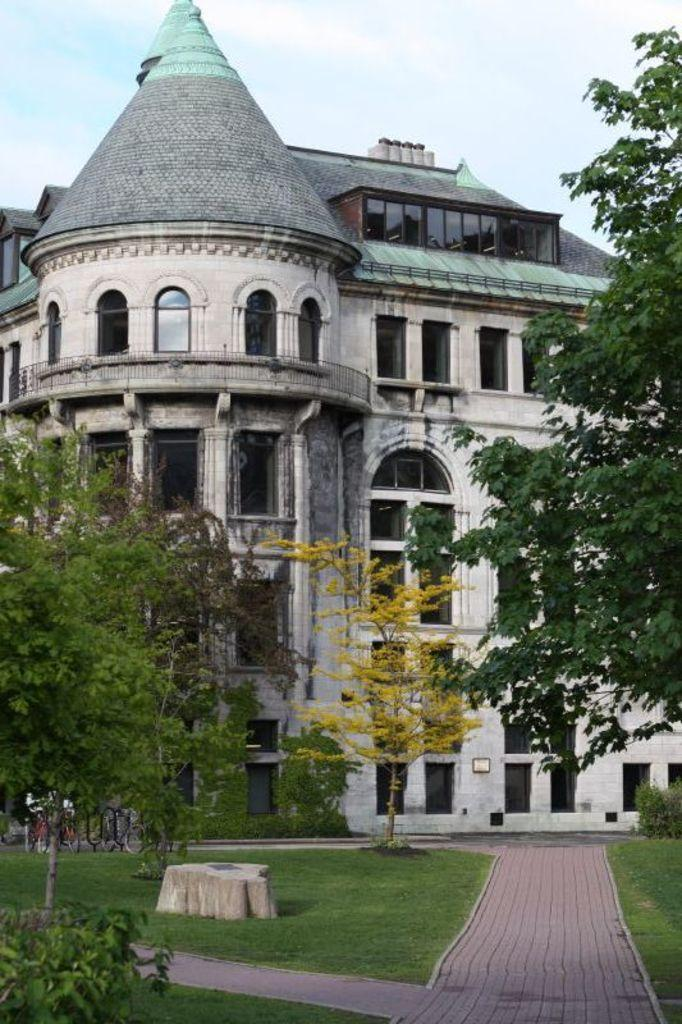What type of surface can be seen in the image? There is a path in the image. What is covering the ground in the image? There is grass on the ground in the image. What type of vegetation is present in the image? There are trees in the image. What type of transportation can be seen in the image? There are bicycles in the image. What type of structure is present in the image? There is a building in the image. What colors are the building in the image? The building is cream, black, and green in color. What is visible in the background of the image? The sky is visible in the background of the image. What type of quartz can be seen in the image? There is no quartz present in the image. What type of notebook is being used by the trees in the image? There are no trees using a notebook in the image. 